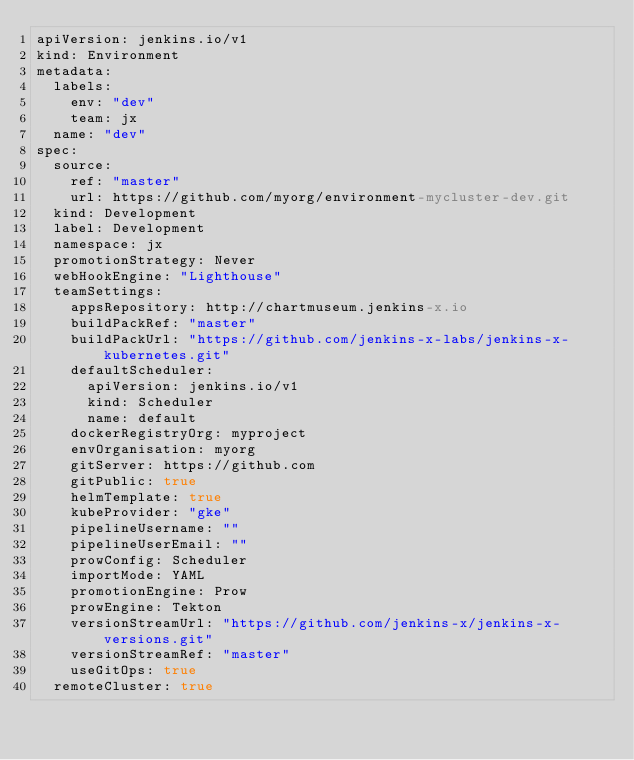<code> <loc_0><loc_0><loc_500><loc_500><_YAML_>apiVersion: jenkins.io/v1
kind: Environment
metadata:
  labels:
    env: "dev"
    team: jx
  name: "dev"
spec:
  source:
    ref: "master"
    url: https://github.com/myorg/environment-mycluster-dev.git
  kind: Development
  label: Development
  namespace: jx
  promotionStrategy: Never
  webHookEngine: "Lighthouse"
  teamSettings:
    appsRepository: http://chartmuseum.jenkins-x.io
    buildPackRef: "master"
    buildPackUrl: "https://github.com/jenkins-x-labs/jenkins-x-kubernetes.git"
    defaultScheduler:
      apiVersion: jenkins.io/v1
      kind: Scheduler
      name: default
    dockerRegistryOrg: myproject
    envOrganisation: myorg
    gitServer: https://github.com
    gitPublic: true
    helmTemplate: true
    kubeProvider: "gke"
    pipelineUsername: ""
    pipelineUserEmail: ""
    prowConfig: Scheduler
    importMode: YAML
    promotionEngine: Prow
    prowEngine: Tekton
    versionStreamUrl: "https://github.com/jenkins-x/jenkins-x-versions.git"
    versionStreamRef: "master"
    useGitOps: true
  remoteCluster: true
</code> 